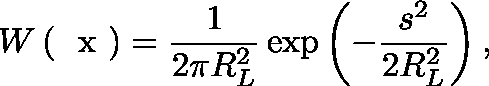<formula> <loc_0><loc_0><loc_500><loc_500>W \left ( \boldmath x \right ) = \frac { 1 } { 2 \pi R _ { L } ^ { 2 } } \exp \left ( - \frac { s ^ { 2 } } { 2 R _ { L } ^ { 2 } } \right ) ,</formula> 